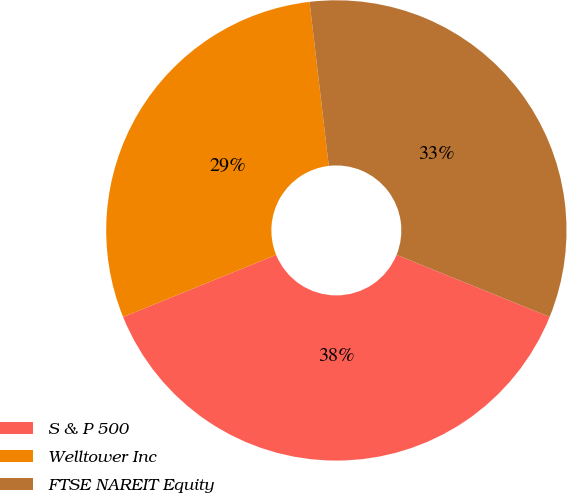<chart> <loc_0><loc_0><loc_500><loc_500><pie_chart><fcel>S & P 500<fcel>Welltower Inc<fcel>FTSE NAREIT Equity<nl><fcel>37.74%<fcel>29.28%<fcel>32.99%<nl></chart> 